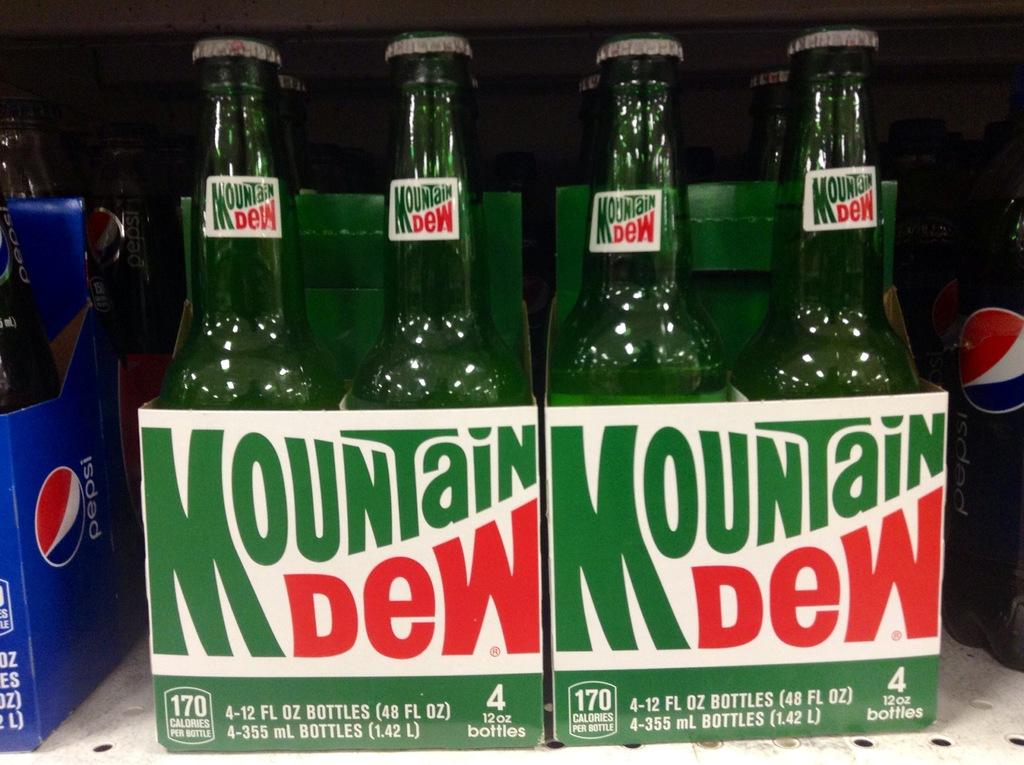What objects are present in the image? There are bottles in the image. How are the bottles depicted? The bottles are highlighted in the image. What brand of soda are the bottles? The bottles are Mountain Dew. What scent can be detected from the bottles in the image? There is no information about the scent of the bottles in the image, as it only shows the bottles themselves. 